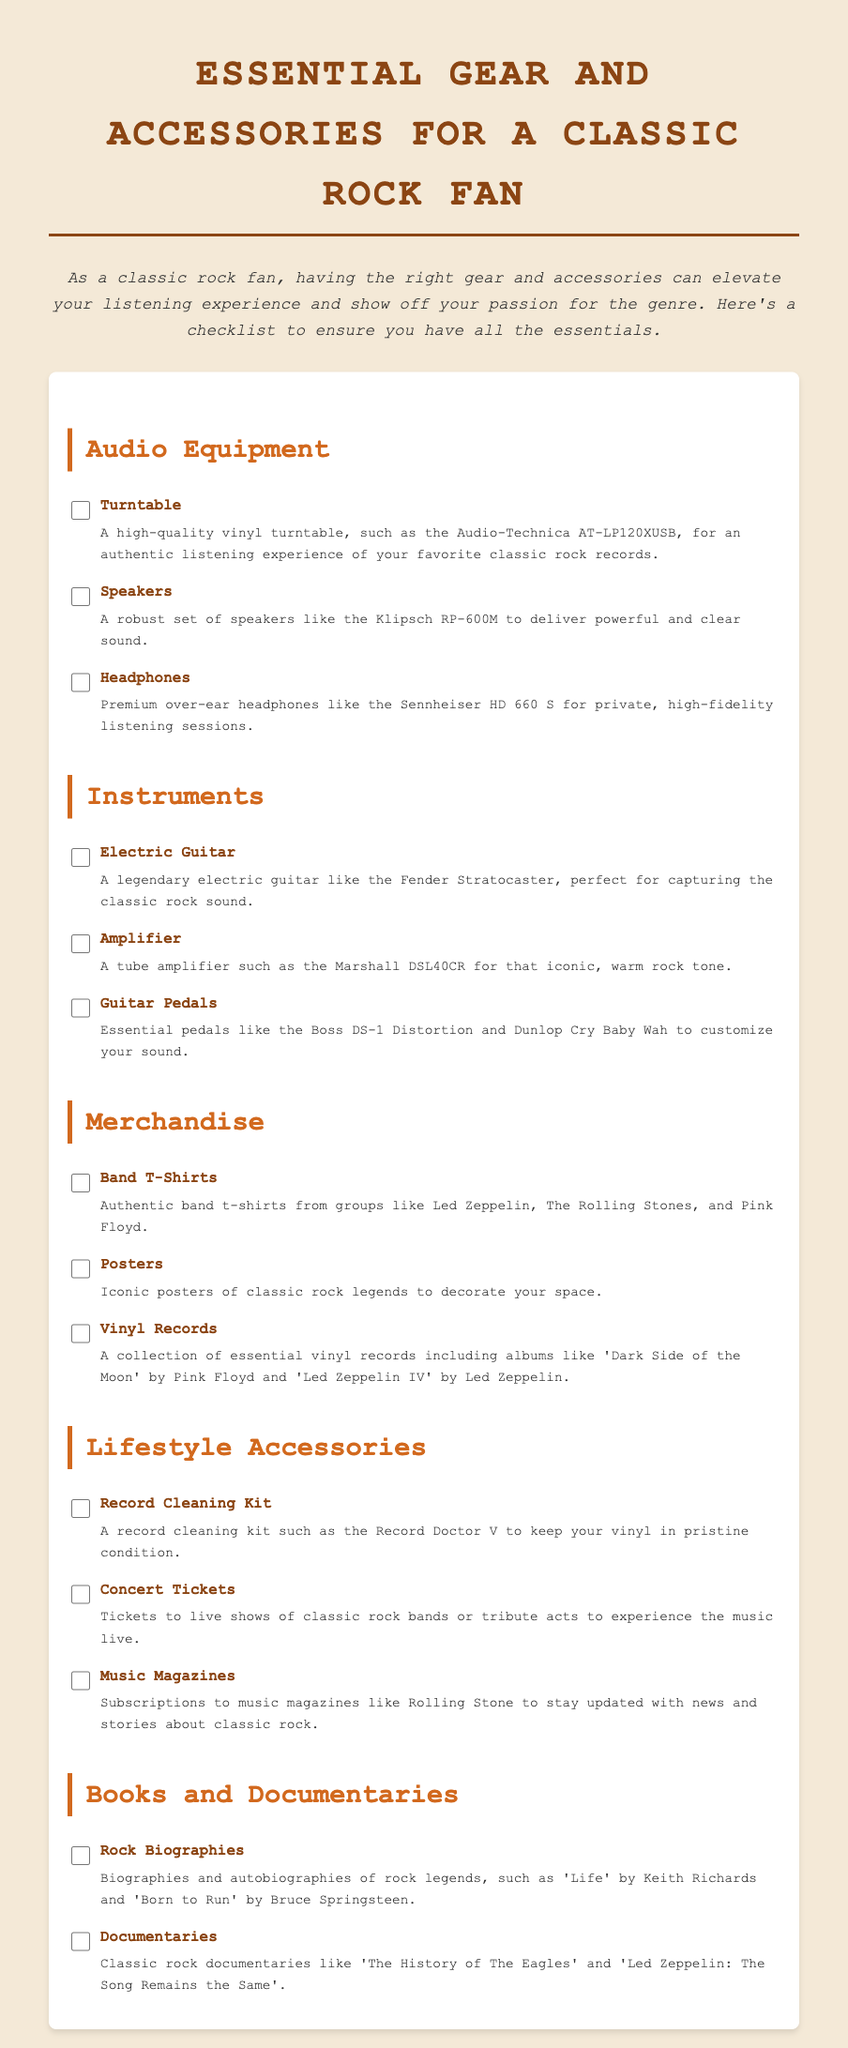What is the first item listed under Audio Equipment? The first item under Audio Equipment is the Turntable, which is specified as a high-quality vinyl turntable.
Answer: Turntable How many types of instruments are listed? The document mentions three types of instruments: Electric Guitar, Amplifier, and Guitar Pedals.
Answer: Three What brand is the recommended electric guitar? The document specifies that the recommended electric guitar is the Fender Stratocaster.
Answer: Fender Stratocaster What is one type of premium headphones mentioned? The document mentions the Sennheiser HD 660 S as a type of premium headphones for high-fidelity listening.
Answer: Sennheiser HD 660 S How many documentary titles are provided? The document lists two documentaries: 'The History of The Eagles' and 'Led Zeppelin: The Song Remains the Same'.
Answer: Two What type of merchandise is suggested besides band t-shirts? Besides band t-shirts, Posters are suggested as merchandise to decorate your space.
Answer: Posters Which record cleaning kit is recommended? The recommended record cleaning kit mentioned is the Record Doctor V.
Answer: Record Doctor V What is the main purpose of the checklist? The checklist aims to ensure classic rock fans have the essential gear and accessories for an optimal listening experience.
Answer: Optimal listening experience 